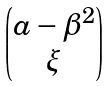Convert formula to latex. <formula><loc_0><loc_0><loc_500><loc_500>\begin{pmatrix} a - \beta ^ { 2 } \\ \xi \end{pmatrix}</formula> 